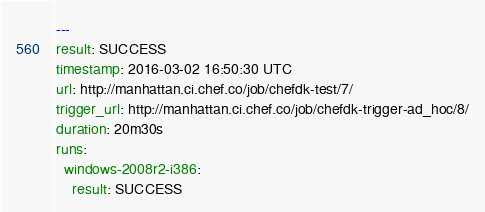<code> <loc_0><loc_0><loc_500><loc_500><_YAML_>---
result: SUCCESS
timestamp: 2016-03-02 16:50:30 UTC
url: http://manhattan.ci.chef.co/job/chefdk-test/7/
trigger_url: http://manhattan.ci.chef.co/job/chefdk-trigger-ad_hoc/8/
duration: 20m30s
runs:
  windows-2008r2-i386:
    result: SUCCESS</code> 